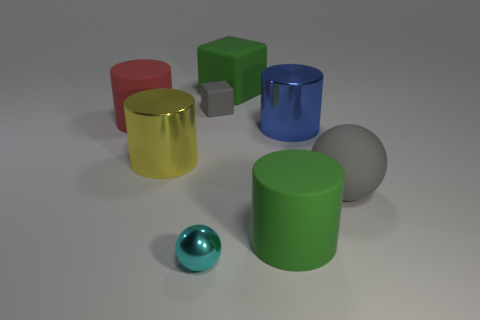There is a big cylinder that is the same color as the big matte block; what material is it?
Your response must be concise. Rubber. Is the large green object that is in front of the big matte cube made of the same material as the large yellow cylinder that is behind the cyan ball?
Ensure brevity in your answer.  No. Is there a blue rubber ball?
Your response must be concise. No. Is the number of large rubber blocks in front of the small gray object greater than the number of small rubber things right of the big green rubber cylinder?
Your answer should be compact. No. What is the material of the tiny cyan object that is the same shape as the large gray thing?
Your answer should be very brief. Metal. Is there any other thing that is the same size as the blue shiny cylinder?
Your response must be concise. Yes. Do the big matte object that is behind the big red thing and the ball left of the gray block have the same color?
Ensure brevity in your answer.  No. What is the shape of the large blue object?
Offer a terse response. Cylinder. Is the number of large yellow things that are on the left side of the big sphere greater than the number of big red matte objects?
Your response must be concise. No. There is a large metallic object that is to the left of the small cyan metal object; what shape is it?
Your response must be concise. Cylinder. 